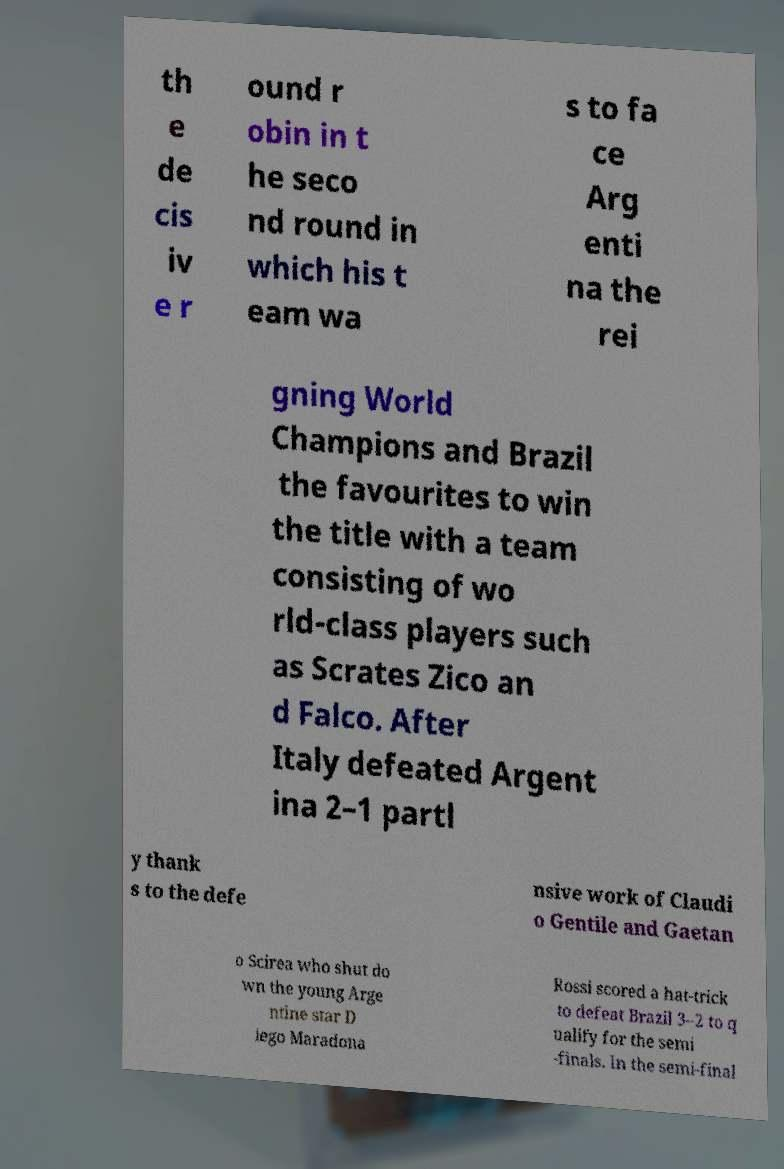There's text embedded in this image that I need extracted. Can you transcribe it verbatim? th e de cis iv e r ound r obin in t he seco nd round in which his t eam wa s to fa ce Arg enti na the rei gning World Champions and Brazil the favourites to win the title with a team consisting of wo rld-class players such as Scrates Zico an d Falco. After Italy defeated Argent ina 2–1 partl y thank s to the defe nsive work of Claudi o Gentile and Gaetan o Scirea who shut do wn the young Arge ntine star D iego Maradona Rossi scored a hat-trick to defeat Brazil 3–2 to q ualify for the semi -finals. In the semi-final 